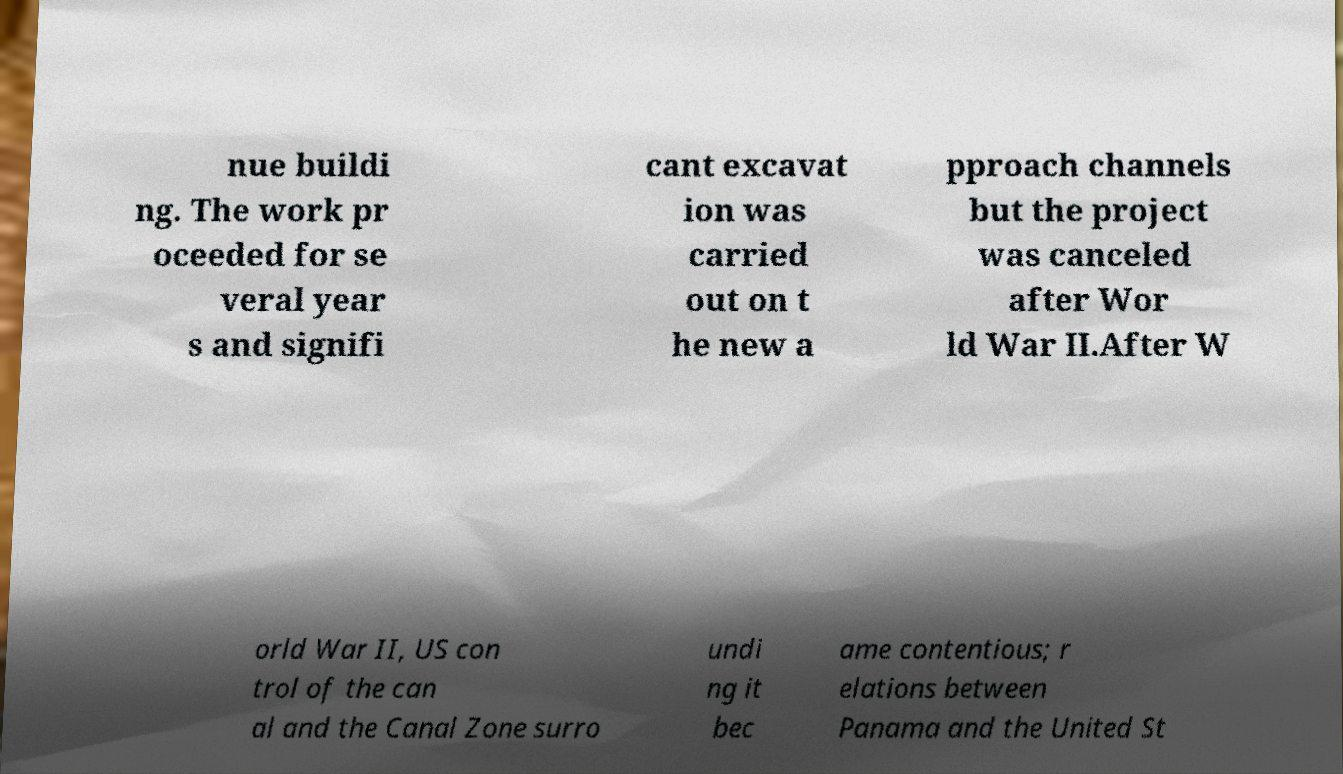What messages or text are displayed in this image? I need them in a readable, typed format. nue buildi ng. The work pr oceeded for se veral year s and signifi cant excavat ion was carried out on t he new a pproach channels but the project was canceled after Wor ld War II.After W orld War II, US con trol of the can al and the Canal Zone surro undi ng it bec ame contentious; r elations between Panama and the United St 